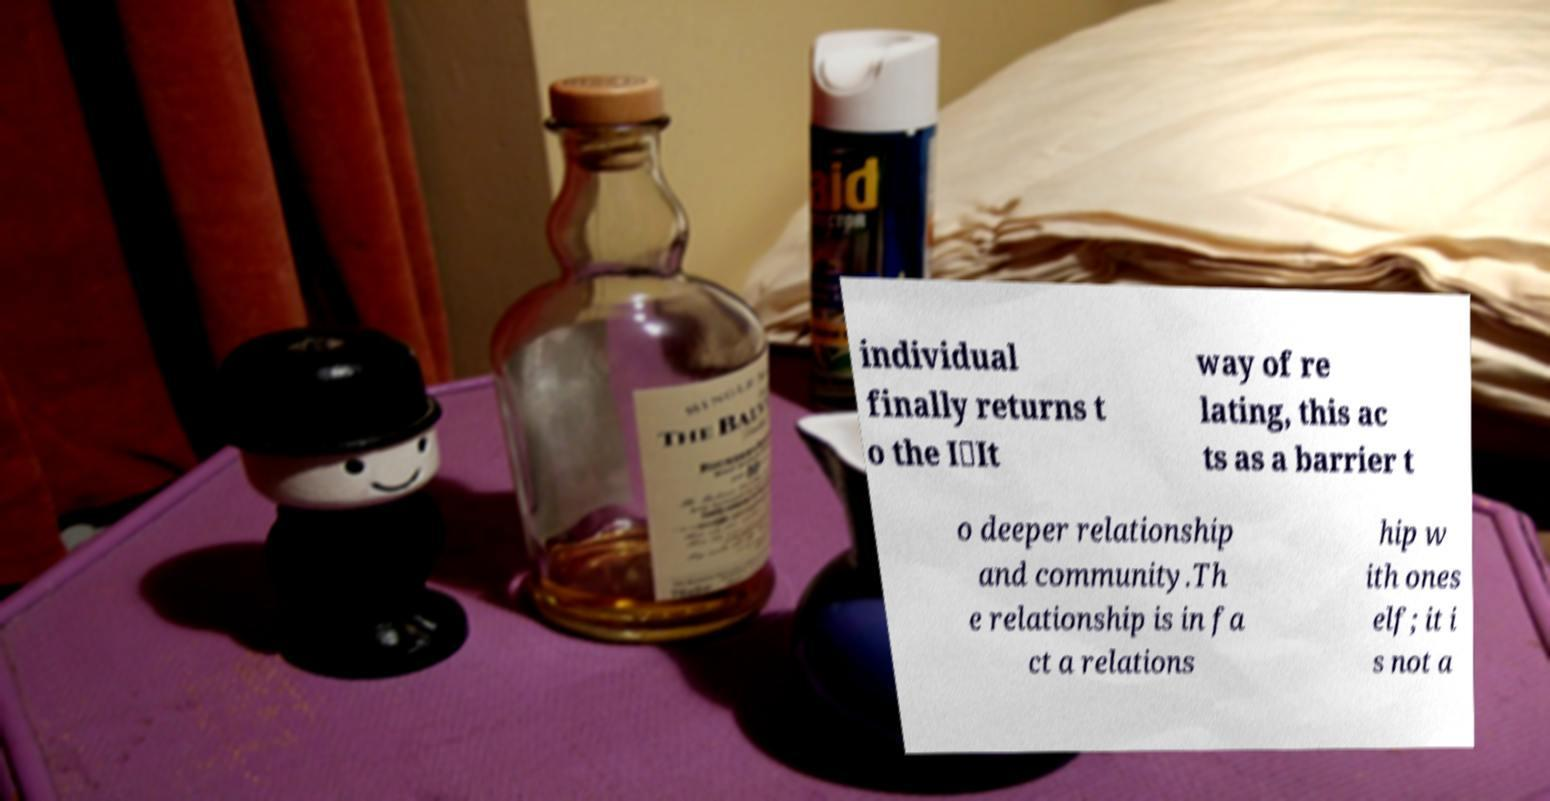For documentation purposes, I need the text within this image transcribed. Could you provide that? individual finally returns t o the I‑It way of re lating, this ac ts as a barrier t o deeper relationship and community.Th e relationship is in fa ct a relations hip w ith ones elf; it i s not a 